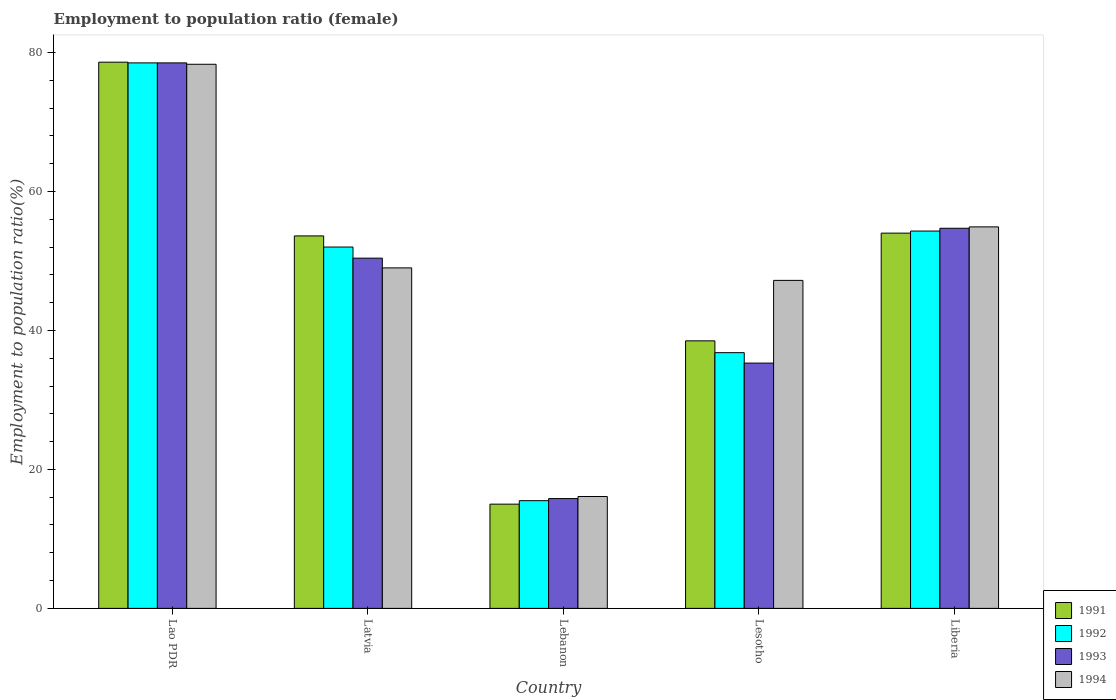How many different coloured bars are there?
Your answer should be very brief. 4. How many groups of bars are there?
Your answer should be compact. 5. Are the number of bars per tick equal to the number of legend labels?
Your answer should be compact. Yes. Are the number of bars on each tick of the X-axis equal?
Offer a terse response. Yes. How many bars are there on the 4th tick from the left?
Keep it short and to the point. 4. How many bars are there on the 1st tick from the right?
Provide a short and direct response. 4. What is the label of the 2nd group of bars from the left?
Offer a very short reply. Latvia. What is the employment to population ratio in 1993 in Liberia?
Make the answer very short. 54.7. Across all countries, what is the maximum employment to population ratio in 1991?
Your answer should be very brief. 78.6. Across all countries, what is the minimum employment to population ratio in 1991?
Your answer should be compact. 15. In which country was the employment to population ratio in 1991 maximum?
Your answer should be very brief. Lao PDR. In which country was the employment to population ratio in 1994 minimum?
Ensure brevity in your answer.  Lebanon. What is the total employment to population ratio in 1992 in the graph?
Ensure brevity in your answer.  237.1. What is the difference between the employment to population ratio in 1991 in Lao PDR and that in Liberia?
Provide a short and direct response. 24.6. What is the difference between the employment to population ratio in 1993 in Latvia and the employment to population ratio in 1994 in Lesotho?
Give a very brief answer. 3.2. What is the average employment to population ratio in 1994 per country?
Make the answer very short. 49.1. What is the difference between the employment to population ratio of/in 1994 and employment to population ratio of/in 1992 in Latvia?
Keep it short and to the point. -3. In how many countries, is the employment to population ratio in 1994 greater than 32 %?
Ensure brevity in your answer.  4. What is the ratio of the employment to population ratio in 1994 in Lao PDR to that in Lesotho?
Give a very brief answer. 1.66. Is the employment to population ratio in 1993 in Lao PDR less than that in Lesotho?
Give a very brief answer. No. What is the difference between the highest and the second highest employment to population ratio in 1992?
Offer a terse response. 2.3. What is the difference between the highest and the lowest employment to population ratio in 1993?
Make the answer very short. 62.7. In how many countries, is the employment to population ratio in 1992 greater than the average employment to population ratio in 1992 taken over all countries?
Provide a succinct answer. 3. Is the sum of the employment to population ratio in 1994 in Latvia and Liberia greater than the maximum employment to population ratio in 1992 across all countries?
Your response must be concise. Yes. Is it the case that in every country, the sum of the employment to population ratio in 1991 and employment to population ratio in 1992 is greater than the sum of employment to population ratio in 1993 and employment to population ratio in 1994?
Give a very brief answer. No. What does the 1st bar from the right in Lao PDR represents?
Provide a short and direct response. 1994. Is it the case that in every country, the sum of the employment to population ratio in 1993 and employment to population ratio in 1991 is greater than the employment to population ratio in 1992?
Give a very brief answer. Yes. How many bars are there?
Ensure brevity in your answer.  20. Does the graph contain any zero values?
Your answer should be very brief. No. How many legend labels are there?
Your response must be concise. 4. How are the legend labels stacked?
Your answer should be very brief. Vertical. What is the title of the graph?
Give a very brief answer. Employment to population ratio (female). Does "1992" appear as one of the legend labels in the graph?
Your response must be concise. Yes. What is the label or title of the X-axis?
Offer a very short reply. Country. What is the label or title of the Y-axis?
Your answer should be compact. Employment to population ratio(%). What is the Employment to population ratio(%) in 1991 in Lao PDR?
Provide a succinct answer. 78.6. What is the Employment to population ratio(%) in 1992 in Lao PDR?
Ensure brevity in your answer.  78.5. What is the Employment to population ratio(%) of 1993 in Lao PDR?
Keep it short and to the point. 78.5. What is the Employment to population ratio(%) of 1994 in Lao PDR?
Offer a terse response. 78.3. What is the Employment to population ratio(%) of 1991 in Latvia?
Offer a very short reply. 53.6. What is the Employment to population ratio(%) of 1993 in Latvia?
Your answer should be compact. 50.4. What is the Employment to population ratio(%) of 1994 in Latvia?
Your answer should be very brief. 49. What is the Employment to population ratio(%) in 1991 in Lebanon?
Keep it short and to the point. 15. What is the Employment to population ratio(%) of 1993 in Lebanon?
Your response must be concise. 15.8. What is the Employment to population ratio(%) of 1994 in Lebanon?
Give a very brief answer. 16.1. What is the Employment to population ratio(%) of 1991 in Lesotho?
Your response must be concise. 38.5. What is the Employment to population ratio(%) in 1992 in Lesotho?
Your answer should be compact. 36.8. What is the Employment to population ratio(%) in 1993 in Lesotho?
Your response must be concise. 35.3. What is the Employment to population ratio(%) of 1994 in Lesotho?
Offer a terse response. 47.2. What is the Employment to population ratio(%) in 1991 in Liberia?
Keep it short and to the point. 54. What is the Employment to population ratio(%) in 1992 in Liberia?
Offer a terse response. 54.3. What is the Employment to population ratio(%) of 1993 in Liberia?
Ensure brevity in your answer.  54.7. What is the Employment to population ratio(%) in 1994 in Liberia?
Offer a very short reply. 54.9. Across all countries, what is the maximum Employment to population ratio(%) of 1991?
Give a very brief answer. 78.6. Across all countries, what is the maximum Employment to population ratio(%) in 1992?
Make the answer very short. 78.5. Across all countries, what is the maximum Employment to population ratio(%) of 1993?
Ensure brevity in your answer.  78.5. Across all countries, what is the maximum Employment to population ratio(%) in 1994?
Offer a very short reply. 78.3. Across all countries, what is the minimum Employment to population ratio(%) of 1992?
Your answer should be very brief. 15.5. Across all countries, what is the minimum Employment to population ratio(%) of 1993?
Make the answer very short. 15.8. Across all countries, what is the minimum Employment to population ratio(%) in 1994?
Ensure brevity in your answer.  16.1. What is the total Employment to population ratio(%) in 1991 in the graph?
Make the answer very short. 239.7. What is the total Employment to population ratio(%) in 1992 in the graph?
Provide a succinct answer. 237.1. What is the total Employment to population ratio(%) of 1993 in the graph?
Your answer should be very brief. 234.7. What is the total Employment to population ratio(%) of 1994 in the graph?
Give a very brief answer. 245.5. What is the difference between the Employment to population ratio(%) of 1991 in Lao PDR and that in Latvia?
Provide a short and direct response. 25. What is the difference between the Employment to population ratio(%) in 1993 in Lao PDR and that in Latvia?
Your response must be concise. 28.1. What is the difference between the Employment to population ratio(%) of 1994 in Lao PDR and that in Latvia?
Give a very brief answer. 29.3. What is the difference between the Employment to population ratio(%) in 1991 in Lao PDR and that in Lebanon?
Provide a short and direct response. 63.6. What is the difference between the Employment to population ratio(%) in 1992 in Lao PDR and that in Lebanon?
Provide a short and direct response. 63. What is the difference between the Employment to population ratio(%) of 1993 in Lao PDR and that in Lebanon?
Offer a terse response. 62.7. What is the difference between the Employment to population ratio(%) in 1994 in Lao PDR and that in Lebanon?
Your answer should be compact. 62.2. What is the difference between the Employment to population ratio(%) in 1991 in Lao PDR and that in Lesotho?
Your answer should be compact. 40.1. What is the difference between the Employment to population ratio(%) in 1992 in Lao PDR and that in Lesotho?
Offer a terse response. 41.7. What is the difference between the Employment to population ratio(%) in 1993 in Lao PDR and that in Lesotho?
Offer a very short reply. 43.2. What is the difference between the Employment to population ratio(%) in 1994 in Lao PDR and that in Lesotho?
Provide a short and direct response. 31.1. What is the difference between the Employment to population ratio(%) in 1991 in Lao PDR and that in Liberia?
Your answer should be compact. 24.6. What is the difference between the Employment to population ratio(%) in 1992 in Lao PDR and that in Liberia?
Your response must be concise. 24.2. What is the difference between the Employment to population ratio(%) in 1993 in Lao PDR and that in Liberia?
Give a very brief answer. 23.8. What is the difference between the Employment to population ratio(%) in 1994 in Lao PDR and that in Liberia?
Provide a short and direct response. 23.4. What is the difference between the Employment to population ratio(%) of 1991 in Latvia and that in Lebanon?
Keep it short and to the point. 38.6. What is the difference between the Employment to population ratio(%) in 1992 in Latvia and that in Lebanon?
Your response must be concise. 36.5. What is the difference between the Employment to population ratio(%) in 1993 in Latvia and that in Lebanon?
Keep it short and to the point. 34.6. What is the difference between the Employment to population ratio(%) of 1994 in Latvia and that in Lebanon?
Provide a succinct answer. 32.9. What is the difference between the Employment to population ratio(%) in 1992 in Latvia and that in Lesotho?
Provide a short and direct response. 15.2. What is the difference between the Employment to population ratio(%) of 1994 in Latvia and that in Lesotho?
Make the answer very short. 1.8. What is the difference between the Employment to population ratio(%) in 1992 in Latvia and that in Liberia?
Make the answer very short. -2.3. What is the difference between the Employment to population ratio(%) in 1993 in Latvia and that in Liberia?
Offer a very short reply. -4.3. What is the difference between the Employment to population ratio(%) in 1994 in Latvia and that in Liberia?
Provide a short and direct response. -5.9. What is the difference between the Employment to population ratio(%) in 1991 in Lebanon and that in Lesotho?
Ensure brevity in your answer.  -23.5. What is the difference between the Employment to population ratio(%) of 1992 in Lebanon and that in Lesotho?
Provide a succinct answer. -21.3. What is the difference between the Employment to population ratio(%) of 1993 in Lebanon and that in Lesotho?
Your answer should be very brief. -19.5. What is the difference between the Employment to population ratio(%) in 1994 in Lebanon and that in Lesotho?
Your answer should be compact. -31.1. What is the difference between the Employment to population ratio(%) of 1991 in Lebanon and that in Liberia?
Ensure brevity in your answer.  -39. What is the difference between the Employment to population ratio(%) of 1992 in Lebanon and that in Liberia?
Offer a terse response. -38.8. What is the difference between the Employment to population ratio(%) of 1993 in Lebanon and that in Liberia?
Provide a succinct answer. -38.9. What is the difference between the Employment to population ratio(%) in 1994 in Lebanon and that in Liberia?
Offer a terse response. -38.8. What is the difference between the Employment to population ratio(%) of 1991 in Lesotho and that in Liberia?
Your answer should be very brief. -15.5. What is the difference between the Employment to population ratio(%) of 1992 in Lesotho and that in Liberia?
Keep it short and to the point. -17.5. What is the difference between the Employment to population ratio(%) in 1993 in Lesotho and that in Liberia?
Offer a terse response. -19.4. What is the difference between the Employment to population ratio(%) in 1994 in Lesotho and that in Liberia?
Give a very brief answer. -7.7. What is the difference between the Employment to population ratio(%) of 1991 in Lao PDR and the Employment to population ratio(%) of 1992 in Latvia?
Give a very brief answer. 26.6. What is the difference between the Employment to population ratio(%) in 1991 in Lao PDR and the Employment to population ratio(%) in 1993 in Latvia?
Provide a short and direct response. 28.2. What is the difference between the Employment to population ratio(%) in 1991 in Lao PDR and the Employment to population ratio(%) in 1994 in Latvia?
Your answer should be very brief. 29.6. What is the difference between the Employment to population ratio(%) in 1992 in Lao PDR and the Employment to population ratio(%) in 1993 in Latvia?
Ensure brevity in your answer.  28.1. What is the difference between the Employment to population ratio(%) of 1992 in Lao PDR and the Employment to population ratio(%) of 1994 in Latvia?
Ensure brevity in your answer.  29.5. What is the difference between the Employment to population ratio(%) of 1993 in Lao PDR and the Employment to population ratio(%) of 1994 in Latvia?
Provide a succinct answer. 29.5. What is the difference between the Employment to population ratio(%) in 1991 in Lao PDR and the Employment to population ratio(%) in 1992 in Lebanon?
Offer a terse response. 63.1. What is the difference between the Employment to population ratio(%) of 1991 in Lao PDR and the Employment to population ratio(%) of 1993 in Lebanon?
Offer a terse response. 62.8. What is the difference between the Employment to population ratio(%) in 1991 in Lao PDR and the Employment to population ratio(%) in 1994 in Lebanon?
Your response must be concise. 62.5. What is the difference between the Employment to population ratio(%) of 1992 in Lao PDR and the Employment to population ratio(%) of 1993 in Lebanon?
Your response must be concise. 62.7. What is the difference between the Employment to population ratio(%) of 1992 in Lao PDR and the Employment to population ratio(%) of 1994 in Lebanon?
Give a very brief answer. 62.4. What is the difference between the Employment to population ratio(%) in 1993 in Lao PDR and the Employment to population ratio(%) in 1994 in Lebanon?
Keep it short and to the point. 62.4. What is the difference between the Employment to population ratio(%) of 1991 in Lao PDR and the Employment to population ratio(%) of 1992 in Lesotho?
Offer a terse response. 41.8. What is the difference between the Employment to population ratio(%) in 1991 in Lao PDR and the Employment to population ratio(%) in 1993 in Lesotho?
Your answer should be very brief. 43.3. What is the difference between the Employment to population ratio(%) in 1991 in Lao PDR and the Employment to population ratio(%) in 1994 in Lesotho?
Offer a very short reply. 31.4. What is the difference between the Employment to population ratio(%) in 1992 in Lao PDR and the Employment to population ratio(%) in 1993 in Lesotho?
Provide a short and direct response. 43.2. What is the difference between the Employment to population ratio(%) in 1992 in Lao PDR and the Employment to population ratio(%) in 1994 in Lesotho?
Your response must be concise. 31.3. What is the difference between the Employment to population ratio(%) of 1993 in Lao PDR and the Employment to population ratio(%) of 1994 in Lesotho?
Your answer should be compact. 31.3. What is the difference between the Employment to population ratio(%) of 1991 in Lao PDR and the Employment to population ratio(%) of 1992 in Liberia?
Your answer should be compact. 24.3. What is the difference between the Employment to population ratio(%) of 1991 in Lao PDR and the Employment to population ratio(%) of 1993 in Liberia?
Keep it short and to the point. 23.9. What is the difference between the Employment to population ratio(%) in 1991 in Lao PDR and the Employment to population ratio(%) in 1994 in Liberia?
Keep it short and to the point. 23.7. What is the difference between the Employment to population ratio(%) of 1992 in Lao PDR and the Employment to population ratio(%) of 1993 in Liberia?
Your response must be concise. 23.8. What is the difference between the Employment to population ratio(%) in 1992 in Lao PDR and the Employment to population ratio(%) in 1994 in Liberia?
Provide a succinct answer. 23.6. What is the difference between the Employment to population ratio(%) of 1993 in Lao PDR and the Employment to population ratio(%) of 1994 in Liberia?
Provide a short and direct response. 23.6. What is the difference between the Employment to population ratio(%) in 1991 in Latvia and the Employment to population ratio(%) in 1992 in Lebanon?
Provide a succinct answer. 38.1. What is the difference between the Employment to population ratio(%) of 1991 in Latvia and the Employment to population ratio(%) of 1993 in Lebanon?
Your answer should be compact. 37.8. What is the difference between the Employment to population ratio(%) of 1991 in Latvia and the Employment to population ratio(%) of 1994 in Lebanon?
Keep it short and to the point. 37.5. What is the difference between the Employment to population ratio(%) of 1992 in Latvia and the Employment to population ratio(%) of 1993 in Lebanon?
Provide a short and direct response. 36.2. What is the difference between the Employment to population ratio(%) of 1992 in Latvia and the Employment to population ratio(%) of 1994 in Lebanon?
Your answer should be very brief. 35.9. What is the difference between the Employment to population ratio(%) in 1993 in Latvia and the Employment to population ratio(%) in 1994 in Lebanon?
Offer a very short reply. 34.3. What is the difference between the Employment to population ratio(%) in 1991 in Latvia and the Employment to population ratio(%) in 1994 in Lesotho?
Provide a succinct answer. 6.4. What is the difference between the Employment to population ratio(%) of 1992 in Latvia and the Employment to population ratio(%) of 1993 in Lesotho?
Give a very brief answer. 16.7. What is the difference between the Employment to population ratio(%) of 1993 in Latvia and the Employment to population ratio(%) of 1994 in Lesotho?
Your answer should be compact. 3.2. What is the difference between the Employment to population ratio(%) in 1991 in Latvia and the Employment to population ratio(%) in 1992 in Liberia?
Your response must be concise. -0.7. What is the difference between the Employment to population ratio(%) in 1991 in Lebanon and the Employment to population ratio(%) in 1992 in Lesotho?
Offer a very short reply. -21.8. What is the difference between the Employment to population ratio(%) of 1991 in Lebanon and the Employment to population ratio(%) of 1993 in Lesotho?
Provide a succinct answer. -20.3. What is the difference between the Employment to population ratio(%) of 1991 in Lebanon and the Employment to population ratio(%) of 1994 in Lesotho?
Ensure brevity in your answer.  -32.2. What is the difference between the Employment to population ratio(%) in 1992 in Lebanon and the Employment to population ratio(%) in 1993 in Lesotho?
Make the answer very short. -19.8. What is the difference between the Employment to population ratio(%) of 1992 in Lebanon and the Employment to population ratio(%) of 1994 in Lesotho?
Provide a succinct answer. -31.7. What is the difference between the Employment to population ratio(%) in 1993 in Lebanon and the Employment to population ratio(%) in 1994 in Lesotho?
Offer a terse response. -31.4. What is the difference between the Employment to population ratio(%) of 1991 in Lebanon and the Employment to population ratio(%) of 1992 in Liberia?
Make the answer very short. -39.3. What is the difference between the Employment to population ratio(%) in 1991 in Lebanon and the Employment to population ratio(%) in 1993 in Liberia?
Offer a very short reply. -39.7. What is the difference between the Employment to population ratio(%) in 1991 in Lebanon and the Employment to population ratio(%) in 1994 in Liberia?
Provide a short and direct response. -39.9. What is the difference between the Employment to population ratio(%) of 1992 in Lebanon and the Employment to population ratio(%) of 1993 in Liberia?
Your response must be concise. -39.2. What is the difference between the Employment to population ratio(%) of 1992 in Lebanon and the Employment to population ratio(%) of 1994 in Liberia?
Offer a terse response. -39.4. What is the difference between the Employment to population ratio(%) in 1993 in Lebanon and the Employment to population ratio(%) in 1994 in Liberia?
Keep it short and to the point. -39.1. What is the difference between the Employment to population ratio(%) in 1991 in Lesotho and the Employment to population ratio(%) in 1992 in Liberia?
Offer a terse response. -15.8. What is the difference between the Employment to population ratio(%) of 1991 in Lesotho and the Employment to population ratio(%) of 1993 in Liberia?
Provide a short and direct response. -16.2. What is the difference between the Employment to population ratio(%) in 1991 in Lesotho and the Employment to population ratio(%) in 1994 in Liberia?
Your answer should be compact. -16.4. What is the difference between the Employment to population ratio(%) in 1992 in Lesotho and the Employment to population ratio(%) in 1993 in Liberia?
Provide a short and direct response. -17.9. What is the difference between the Employment to population ratio(%) of 1992 in Lesotho and the Employment to population ratio(%) of 1994 in Liberia?
Make the answer very short. -18.1. What is the difference between the Employment to population ratio(%) of 1993 in Lesotho and the Employment to population ratio(%) of 1994 in Liberia?
Provide a succinct answer. -19.6. What is the average Employment to population ratio(%) of 1991 per country?
Keep it short and to the point. 47.94. What is the average Employment to population ratio(%) of 1992 per country?
Your answer should be very brief. 47.42. What is the average Employment to population ratio(%) in 1993 per country?
Give a very brief answer. 46.94. What is the average Employment to population ratio(%) of 1994 per country?
Offer a terse response. 49.1. What is the difference between the Employment to population ratio(%) in 1991 and Employment to population ratio(%) in 1992 in Lao PDR?
Offer a terse response. 0.1. What is the difference between the Employment to population ratio(%) in 1991 and Employment to population ratio(%) in 1994 in Lao PDR?
Ensure brevity in your answer.  0.3. What is the difference between the Employment to population ratio(%) in 1992 and Employment to population ratio(%) in 1993 in Lao PDR?
Ensure brevity in your answer.  0. What is the difference between the Employment to population ratio(%) of 1991 and Employment to population ratio(%) of 1992 in Latvia?
Provide a short and direct response. 1.6. What is the difference between the Employment to population ratio(%) of 1991 and Employment to population ratio(%) of 1993 in Latvia?
Ensure brevity in your answer.  3.2. What is the difference between the Employment to population ratio(%) in 1992 and Employment to population ratio(%) in 1994 in Latvia?
Your answer should be very brief. 3. What is the difference between the Employment to population ratio(%) of 1991 and Employment to population ratio(%) of 1993 in Lebanon?
Your answer should be compact. -0.8. What is the difference between the Employment to population ratio(%) of 1991 and Employment to population ratio(%) of 1994 in Lebanon?
Your answer should be very brief. -1.1. What is the difference between the Employment to population ratio(%) of 1992 and Employment to population ratio(%) of 1993 in Lebanon?
Offer a very short reply. -0.3. What is the difference between the Employment to population ratio(%) in 1992 and Employment to population ratio(%) in 1994 in Lebanon?
Offer a very short reply. -0.6. What is the difference between the Employment to population ratio(%) of 1992 and Employment to population ratio(%) of 1993 in Lesotho?
Keep it short and to the point. 1.5. What is the difference between the Employment to population ratio(%) of 1992 and Employment to population ratio(%) of 1994 in Lesotho?
Ensure brevity in your answer.  -10.4. What is the difference between the Employment to population ratio(%) of 1993 and Employment to population ratio(%) of 1994 in Lesotho?
Your answer should be compact. -11.9. What is the difference between the Employment to population ratio(%) of 1991 and Employment to population ratio(%) of 1992 in Liberia?
Your answer should be compact. -0.3. What is the difference between the Employment to population ratio(%) in 1991 and Employment to population ratio(%) in 1993 in Liberia?
Your answer should be compact. -0.7. What is the difference between the Employment to population ratio(%) in 1992 and Employment to population ratio(%) in 1993 in Liberia?
Ensure brevity in your answer.  -0.4. What is the ratio of the Employment to population ratio(%) of 1991 in Lao PDR to that in Latvia?
Offer a very short reply. 1.47. What is the ratio of the Employment to population ratio(%) in 1992 in Lao PDR to that in Latvia?
Your answer should be very brief. 1.51. What is the ratio of the Employment to population ratio(%) in 1993 in Lao PDR to that in Latvia?
Make the answer very short. 1.56. What is the ratio of the Employment to population ratio(%) in 1994 in Lao PDR to that in Latvia?
Offer a very short reply. 1.6. What is the ratio of the Employment to population ratio(%) of 1991 in Lao PDR to that in Lebanon?
Offer a terse response. 5.24. What is the ratio of the Employment to population ratio(%) of 1992 in Lao PDR to that in Lebanon?
Ensure brevity in your answer.  5.06. What is the ratio of the Employment to population ratio(%) of 1993 in Lao PDR to that in Lebanon?
Make the answer very short. 4.97. What is the ratio of the Employment to population ratio(%) in 1994 in Lao PDR to that in Lebanon?
Give a very brief answer. 4.86. What is the ratio of the Employment to population ratio(%) in 1991 in Lao PDR to that in Lesotho?
Give a very brief answer. 2.04. What is the ratio of the Employment to population ratio(%) of 1992 in Lao PDR to that in Lesotho?
Offer a terse response. 2.13. What is the ratio of the Employment to population ratio(%) in 1993 in Lao PDR to that in Lesotho?
Your answer should be very brief. 2.22. What is the ratio of the Employment to population ratio(%) in 1994 in Lao PDR to that in Lesotho?
Provide a succinct answer. 1.66. What is the ratio of the Employment to population ratio(%) in 1991 in Lao PDR to that in Liberia?
Make the answer very short. 1.46. What is the ratio of the Employment to population ratio(%) in 1992 in Lao PDR to that in Liberia?
Keep it short and to the point. 1.45. What is the ratio of the Employment to population ratio(%) in 1993 in Lao PDR to that in Liberia?
Make the answer very short. 1.44. What is the ratio of the Employment to population ratio(%) of 1994 in Lao PDR to that in Liberia?
Your answer should be very brief. 1.43. What is the ratio of the Employment to population ratio(%) of 1991 in Latvia to that in Lebanon?
Give a very brief answer. 3.57. What is the ratio of the Employment to population ratio(%) in 1992 in Latvia to that in Lebanon?
Offer a terse response. 3.35. What is the ratio of the Employment to population ratio(%) in 1993 in Latvia to that in Lebanon?
Your answer should be compact. 3.19. What is the ratio of the Employment to population ratio(%) of 1994 in Latvia to that in Lebanon?
Your answer should be compact. 3.04. What is the ratio of the Employment to population ratio(%) of 1991 in Latvia to that in Lesotho?
Your answer should be very brief. 1.39. What is the ratio of the Employment to population ratio(%) in 1992 in Latvia to that in Lesotho?
Your answer should be compact. 1.41. What is the ratio of the Employment to population ratio(%) in 1993 in Latvia to that in Lesotho?
Offer a terse response. 1.43. What is the ratio of the Employment to population ratio(%) of 1994 in Latvia to that in Lesotho?
Your response must be concise. 1.04. What is the ratio of the Employment to population ratio(%) of 1991 in Latvia to that in Liberia?
Your response must be concise. 0.99. What is the ratio of the Employment to population ratio(%) in 1992 in Latvia to that in Liberia?
Ensure brevity in your answer.  0.96. What is the ratio of the Employment to population ratio(%) in 1993 in Latvia to that in Liberia?
Make the answer very short. 0.92. What is the ratio of the Employment to population ratio(%) in 1994 in Latvia to that in Liberia?
Your response must be concise. 0.89. What is the ratio of the Employment to population ratio(%) in 1991 in Lebanon to that in Lesotho?
Your answer should be very brief. 0.39. What is the ratio of the Employment to population ratio(%) of 1992 in Lebanon to that in Lesotho?
Make the answer very short. 0.42. What is the ratio of the Employment to population ratio(%) in 1993 in Lebanon to that in Lesotho?
Give a very brief answer. 0.45. What is the ratio of the Employment to population ratio(%) of 1994 in Lebanon to that in Lesotho?
Ensure brevity in your answer.  0.34. What is the ratio of the Employment to population ratio(%) of 1991 in Lebanon to that in Liberia?
Provide a short and direct response. 0.28. What is the ratio of the Employment to population ratio(%) of 1992 in Lebanon to that in Liberia?
Offer a very short reply. 0.29. What is the ratio of the Employment to population ratio(%) of 1993 in Lebanon to that in Liberia?
Ensure brevity in your answer.  0.29. What is the ratio of the Employment to population ratio(%) in 1994 in Lebanon to that in Liberia?
Ensure brevity in your answer.  0.29. What is the ratio of the Employment to population ratio(%) of 1991 in Lesotho to that in Liberia?
Your answer should be compact. 0.71. What is the ratio of the Employment to population ratio(%) of 1992 in Lesotho to that in Liberia?
Offer a terse response. 0.68. What is the ratio of the Employment to population ratio(%) of 1993 in Lesotho to that in Liberia?
Give a very brief answer. 0.65. What is the ratio of the Employment to population ratio(%) in 1994 in Lesotho to that in Liberia?
Offer a terse response. 0.86. What is the difference between the highest and the second highest Employment to population ratio(%) in 1991?
Provide a short and direct response. 24.6. What is the difference between the highest and the second highest Employment to population ratio(%) in 1992?
Your answer should be very brief. 24.2. What is the difference between the highest and the second highest Employment to population ratio(%) in 1993?
Ensure brevity in your answer.  23.8. What is the difference between the highest and the second highest Employment to population ratio(%) in 1994?
Give a very brief answer. 23.4. What is the difference between the highest and the lowest Employment to population ratio(%) in 1991?
Give a very brief answer. 63.6. What is the difference between the highest and the lowest Employment to population ratio(%) of 1993?
Provide a short and direct response. 62.7. What is the difference between the highest and the lowest Employment to population ratio(%) in 1994?
Ensure brevity in your answer.  62.2. 